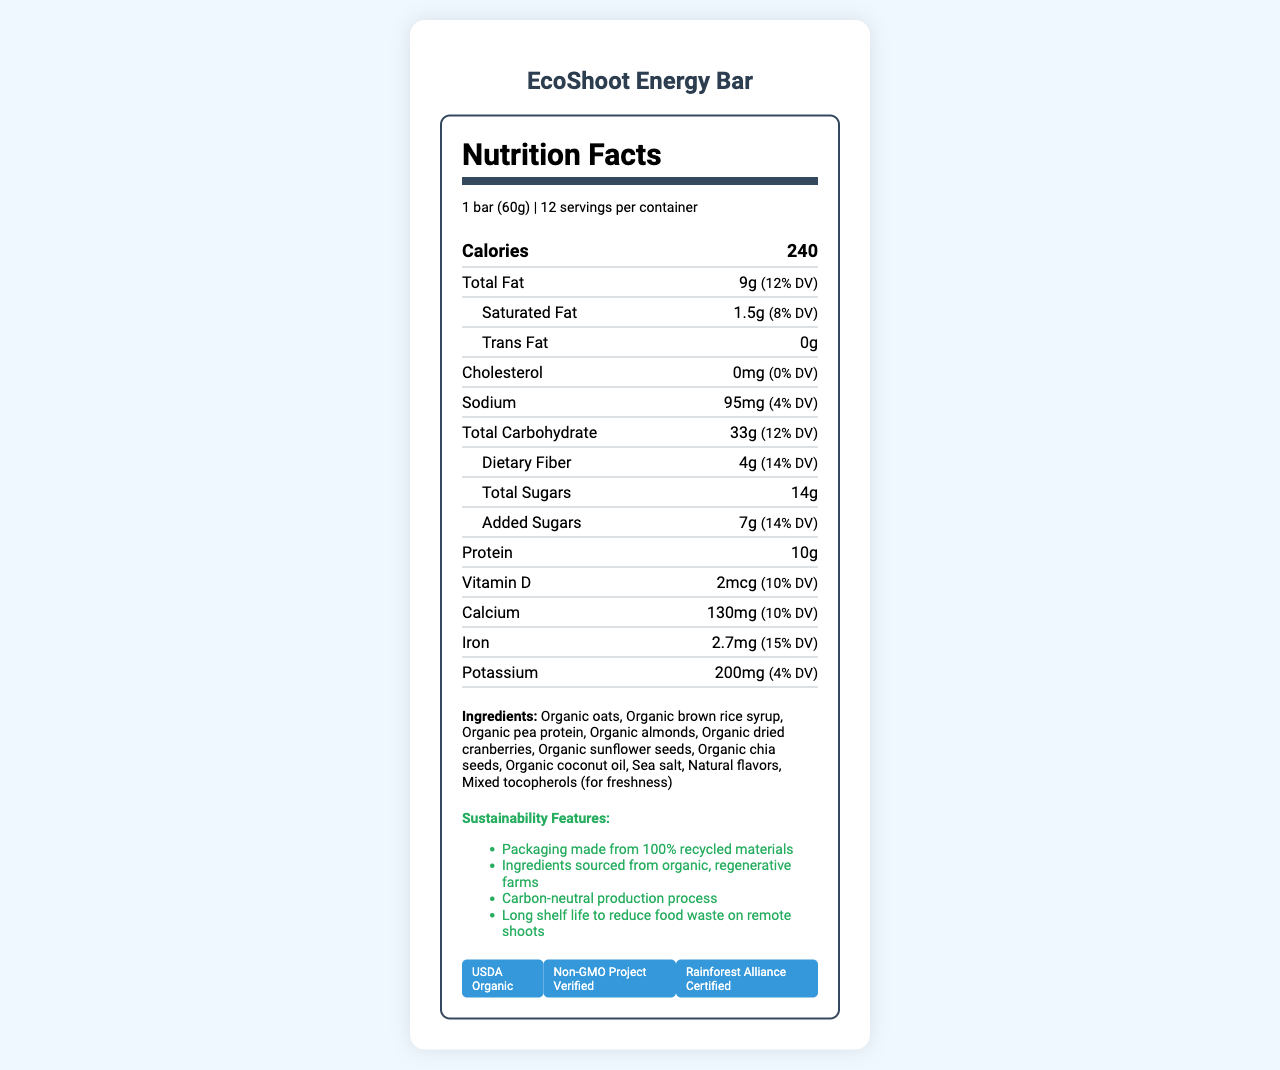what is the serving size of the EcoShoot Energy Bar? The serving size is stated as "1 bar (60g)" in the document.
Answer: 1 bar (60g) how many servings are there per container? The document mentions that there are 12 servings per container.
Answer: 12 what is the total fat content per serving and its daily value percentage? The document states that the total fat content is 9 grams and it provides 12% of the daily value.
Answer: 9g, 12% DV how much protein is in one serving of the EcoShoot Energy Bar? The amount of protein per serving is given as 10 grams.
Answer: 10g name two vitamins present in the EcoShoot Energy Bar and their daily value percentages. The document lists Vitamin D with 10% DV and Vitamin B12 with 25% DV.
Answer: Vitamin D - 10%, Vitamin B12 - 25% which of these vitamins has the highest daily value percentage in the EcoShoot Energy Bar? A. Vitamin A B. Vitamin C C. Vitamin E D. Vitamin B12 Vitamin B12 has a daily value percentage of 25%, which is the highest among the options provided.
Answer: D (Vitamin B12) which ingredient in the EcoShoot Energy Bar could pose a concern for people with nut allergies? A. Organic oats B. Organic almonds C. Sea salt The allergen information states that the product contains almonds, and almonds are a type of tree nut.
Answer: B (Organic almonds) is the product certified as Non-GMO? One of the certifications listed for the product is "Non-GMO Project Verified".
Answer: Yes does the EcoShoot Energy Bar contain trans fat? The document indicates that the trans fat amount per serving is 0 grams.
Answer: No describe the main idea of the entire document. The document includes information on serving size, calorie content, various nutrient amounts and their daily values, ingredient list, presence of allergens, sustainable practices involved in production and packaging, and relevant certifications.
Answer: The document provides a detailed breakdown of the nutrition facts, ingredients, allergen information, sustainability features, storage instructions, and certifications for the EcoShoot Energy Bar. how long can the EcoShoot Energy Bar be stored before consumption? The storage instructions specify that the product should be consumed within 18 months of the production date.
Answer: 18 months how much added sugar is in one serving of the EcoShoot Energy Bar? The nutrition label states that there are 7 grams of added sugars per serving.
Answer: 7g which mineral has the highest daily value percentage in one serving of the EcoShoot Energy Bar? The daily value percentage for iron is the highest among the listed minerals in the document, which is 15%.
Answer: Iron - 15% DV can it be determined from the document what the specific production date of the EcoShoot Energy Bar is? The document does not provide any specific information about the production date of the product.
Answer: Not enough information 